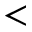Convert formula to latex. <formula><loc_0><loc_0><loc_500><loc_500><</formula> 